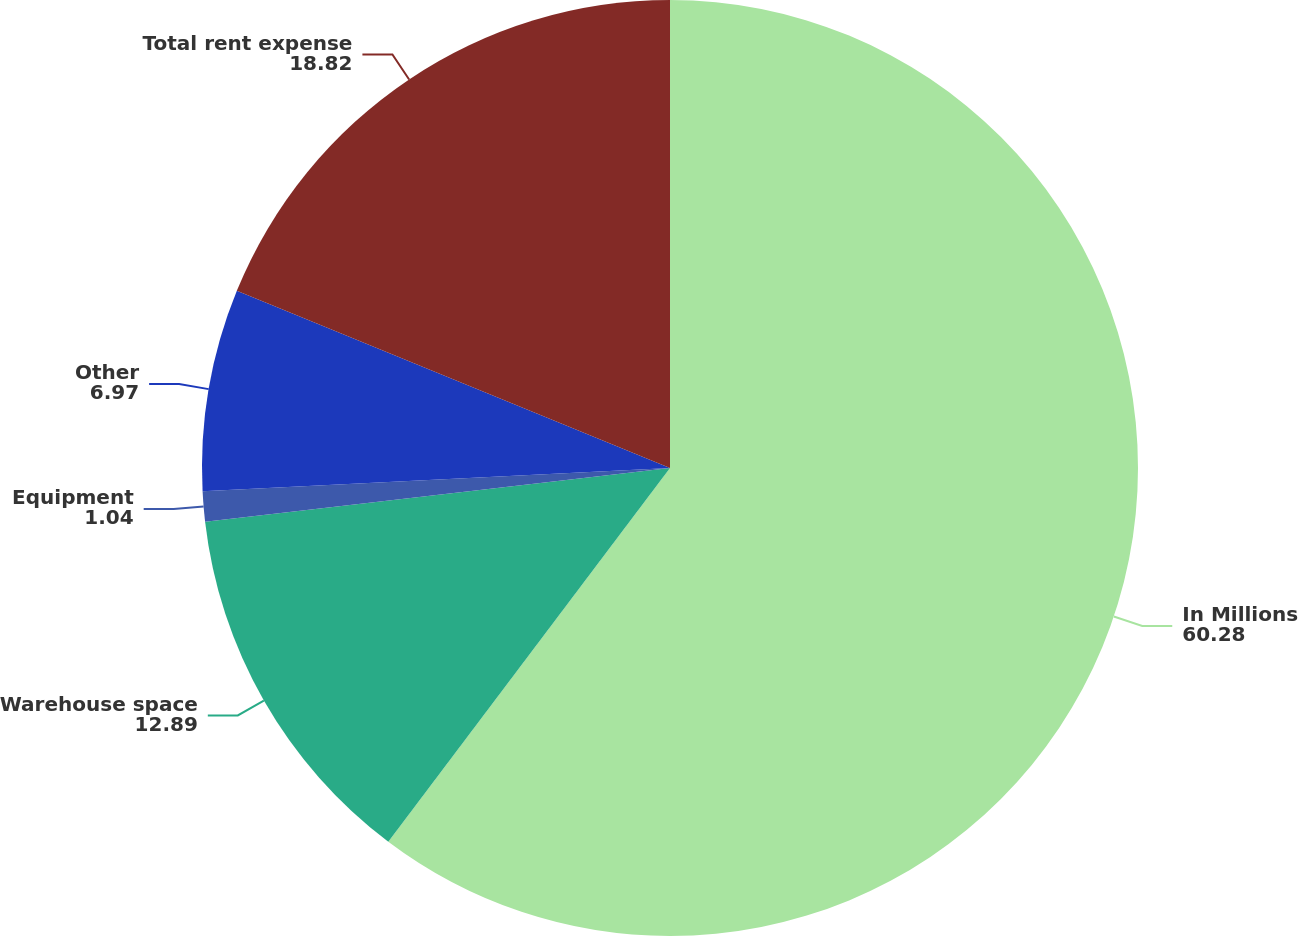<chart> <loc_0><loc_0><loc_500><loc_500><pie_chart><fcel>In Millions<fcel>Warehouse space<fcel>Equipment<fcel>Other<fcel>Total rent expense<nl><fcel>60.28%<fcel>12.89%<fcel>1.04%<fcel>6.97%<fcel>18.82%<nl></chart> 